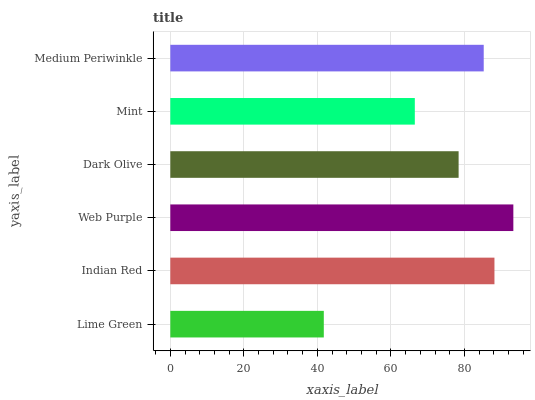Is Lime Green the minimum?
Answer yes or no. Yes. Is Web Purple the maximum?
Answer yes or no. Yes. Is Indian Red the minimum?
Answer yes or no. No. Is Indian Red the maximum?
Answer yes or no. No. Is Indian Red greater than Lime Green?
Answer yes or no. Yes. Is Lime Green less than Indian Red?
Answer yes or no. Yes. Is Lime Green greater than Indian Red?
Answer yes or no. No. Is Indian Red less than Lime Green?
Answer yes or no. No. Is Medium Periwinkle the high median?
Answer yes or no. Yes. Is Dark Olive the low median?
Answer yes or no. Yes. Is Lime Green the high median?
Answer yes or no. No. Is Medium Periwinkle the low median?
Answer yes or no. No. 